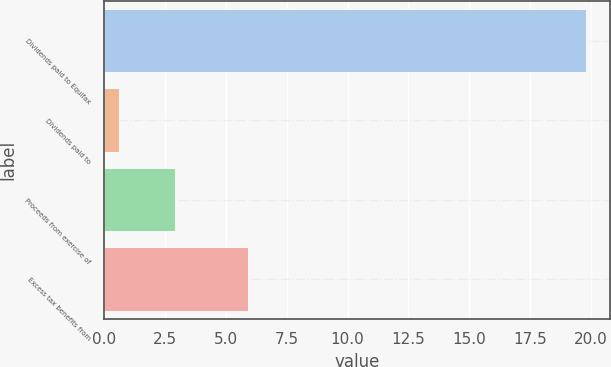Convert chart. <chart><loc_0><loc_0><loc_500><loc_500><bar_chart><fcel>Dividends paid to Equifax<fcel>Dividends paid to<fcel>Proceeds from exercise of<fcel>Excess tax benefits from<nl><fcel>19.8<fcel>0.6<fcel>2.9<fcel>5.9<nl></chart> 